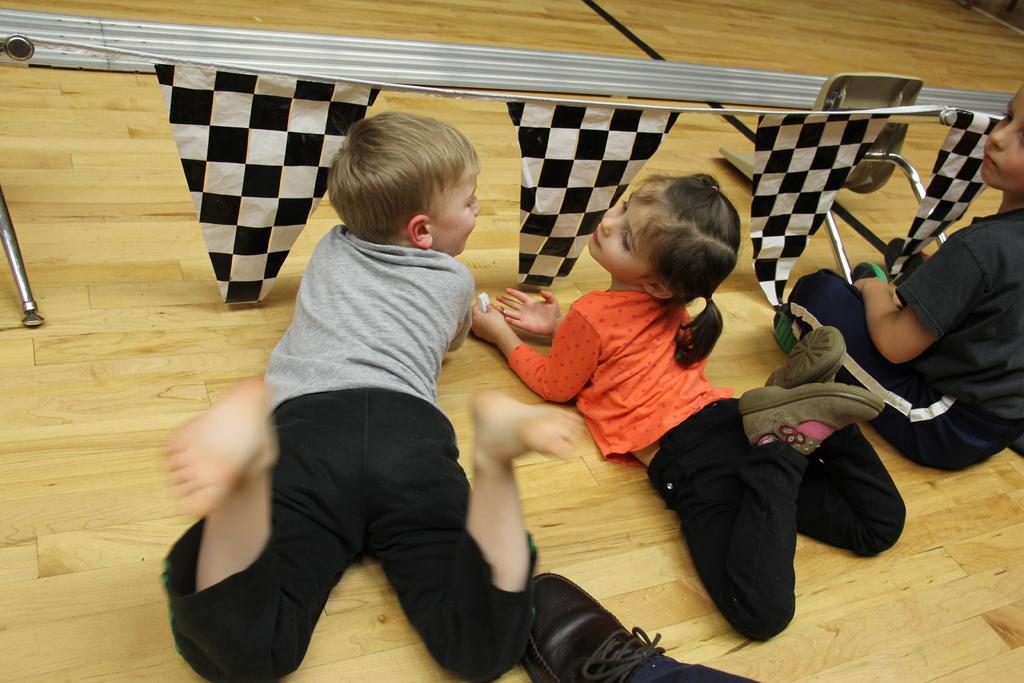What is the position of the kid in the image? There is a kid sitting in the image. How many kids are laying down in the image? There are two kids laying in the image. What can be seen in the background of the image? There are flags in the image. What type of flooring is visible at the bottom of the image? There is a wooden floor at the bottom of the image. What type of pear is the actor holding in the image? There is no actor or pear present in the image. Is there a notebook visible on the wooden floor in the image? There is no notebook visible on the wooden floor in the image. 